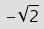<formula> <loc_0><loc_0><loc_500><loc_500>- \sqrt { 2 }</formula> 